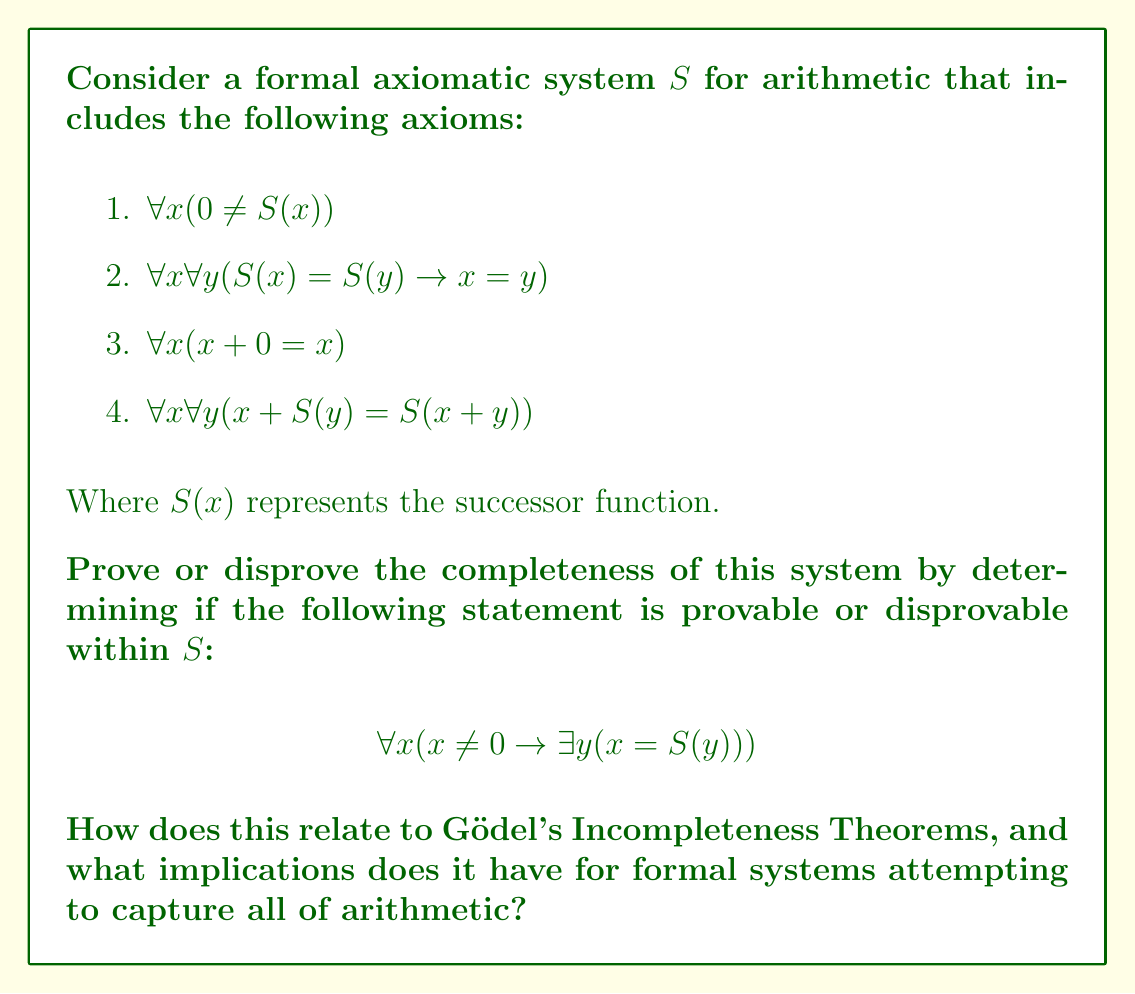Can you solve this math problem? To analyze the completeness of the given formal axiomatic system $S$, we need to determine if the statement $\forall x (x \neq 0 \rightarrow \exists y (x = S(y)))$ is provable or disprovable within $S$. This statement essentially claims that every non-zero number has a predecessor.

Let's break down the analysis:

1. The given axioms define basic properties of the successor function and addition but do not directly address the existence of predecessors for all non-zero numbers.

2. We cannot prove the statement using the given axioms because:
   a. There's no axiom that directly states the existence of predecessors.
   b. The axioms don't provide a way to "work backwards" from a number to its predecessor.

3. We also cannot disprove the statement within the system because:
   a. The axioms don't rule out the possibility of predecessors existing.
   b. There's no contradiction that arises from assuming the statement is true.

This situation demonstrates that the system $S$ is incomplete. There exists a well-formed statement in the language of the system that can neither be proved nor disproved using the axioms of $S$.

Relation to Gödel's Incompleteness Theorems:

1. First Incompleteness Theorem: This situation aligns with Gödel's First Incompleteness Theorem, which states that for any consistent formal system $F$ within which a certain amount of elementary arithmetic can be carried out, there are statements of the language of $F$ which can neither be proved nor disproved in $F$.

2. Second Incompleteness Theorem: While not directly demonstrated here, this example sets the stage for understanding the Second Incompleteness Theorem, which states that such a system cannot prove its own consistency within itself.

Implications for formal systems:

1. Limitation of Axiomatic Systems: This example shows that even seemingly comprehensive axiomatic systems can have gaps, unable to prove or disprove certain statements within their own framework.

2. Need for Meta-Mathematical Considerations: To fully understand arithmetic, we often need to step outside the system and use meta-mathematical reasoning.

3. Trade-off between Completeness and Consistency: As per Gödel's theorems, we can't have a consistent and complete axiomatic system that encompasses all of arithmetic.

4. Ongoing Nature of Mathematical Foundations: This underscores the ongoing work in mathematical logic to understand the limits and capabilities of formal systems.

For a University of Pennsylvania student, this analysis demonstrates the deep and sometimes counterintuitive nature of mathematical logic, highlighting why courses in foundations of mathematics are crucial in a comprehensive math education, regardless of the institution's Ivy League status.
Answer: The given formal axiomatic system $S$ is incomplete. The statement $\forall x (x \neq 0 \rightarrow \exists y (x = S(y)))$ is neither provable nor disprovable within $S$, demonstrating a limitation in the system's ability to capture all truths about arithmetic. This aligns with Gödel's First Incompleteness Theorem and illustrates the inherent limitations of formal axiomatic systems in fully describing arithmetic. 